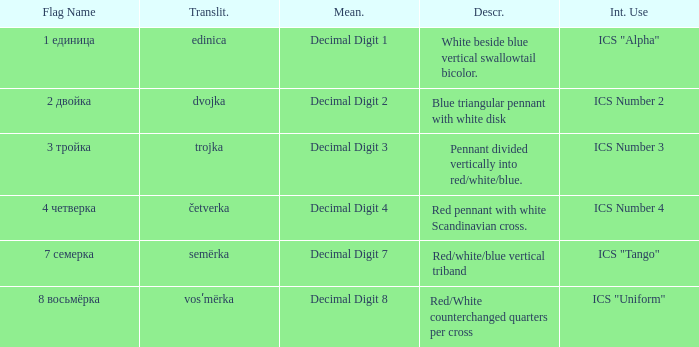How many different descriptions are there for the flag that means decimal digit 2? 1.0. 